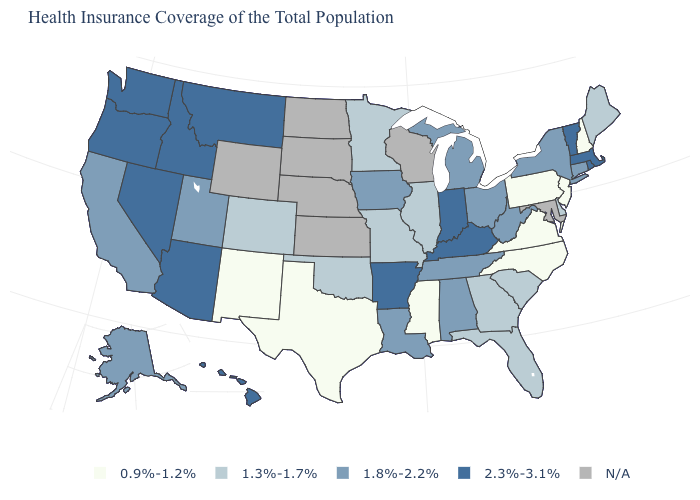What is the highest value in the USA?
Quick response, please. 2.3%-3.1%. What is the value of Kansas?
Write a very short answer. N/A. How many symbols are there in the legend?
Answer briefly. 5. What is the value of Louisiana?
Short answer required. 1.8%-2.2%. What is the value of Minnesota?
Write a very short answer. 1.3%-1.7%. How many symbols are there in the legend?
Short answer required. 5. Which states have the lowest value in the USA?
Answer briefly. Mississippi, New Hampshire, New Jersey, New Mexico, North Carolina, Pennsylvania, Texas, Virginia. What is the value of Georgia?
Short answer required. 1.3%-1.7%. What is the value of Illinois?
Give a very brief answer. 1.3%-1.7%. Name the states that have a value in the range 1.8%-2.2%?
Write a very short answer. Alabama, Alaska, California, Connecticut, Iowa, Louisiana, Michigan, New York, Ohio, Tennessee, Utah, West Virginia. What is the value of Hawaii?
Concise answer only. 2.3%-3.1%. Does Illinois have the lowest value in the MidWest?
Be succinct. Yes. Among the states that border New York , which have the highest value?
Short answer required. Massachusetts, Vermont. Among the states that border Iowa , which have the lowest value?
Answer briefly. Illinois, Minnesota, Missouri. What is the value of Minnesota?
Be succinct. 1.3%-1.7%. 